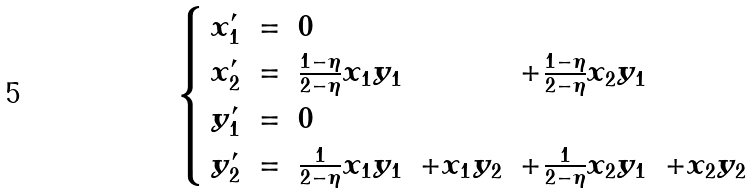Convert formula to latex. <formula><loc_0><loc_0><loc_500><loc_500>\begin{cases} \begin{array} { c c l l l l } x _ { 1 } ^ { \prime } & = & 0 \\ x _ { 2 } ^ { \prime } & = & \frac { 1 - \eta } { 2 - \eta } x _ { 1 } y _ { 1 } & & + \frac { 1 - \eta } { 2 - \eta } x _ { 2 } y _ { 1 } \\ y _ { 1 } ^ { \prime } & = & 0 \\ y _ { 2 } ^ { \prime } & = & \frac { 1 } { 2 - \eta } x _ { 1 } y _ { 1 } & + x _ { 1 } y _ { 2 } & + \frac { 1 } { 2 - \eta } x _ { 2 } y _ { 1 } & + x _ { 2 } y _ { 2 } \end{array} \end{cases}</formula> 